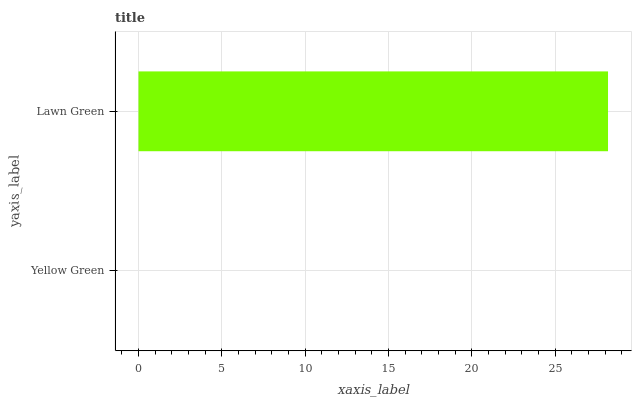Is Yellow Green the minimum?
Answer yes or no. Yes. Is Lawn Green the maximum?
Answer yes or no. Yes. Is Lawn Green the minimum?
Answer yes or no. No. Is Lawn Green greater than Yellow Green?
Answer yes or no. Yes. Is Yellow Green less than Lawn Green?
Answer yes or no. Yes. Is Yellow Green greater than Lawn Green?
Answer yes or no. No. Is Lawn Green less than Yellow Green?
Answer yes or no. No. Is Lawn Green the high median?
Answer yes or no. Yes. Is Yellow Green the low median?
Answer yes or no. Yes. Is Yellow Green the high median?
Answer yes or no. No. Is Lawn Green the low median?
Answer yes or no. No. 